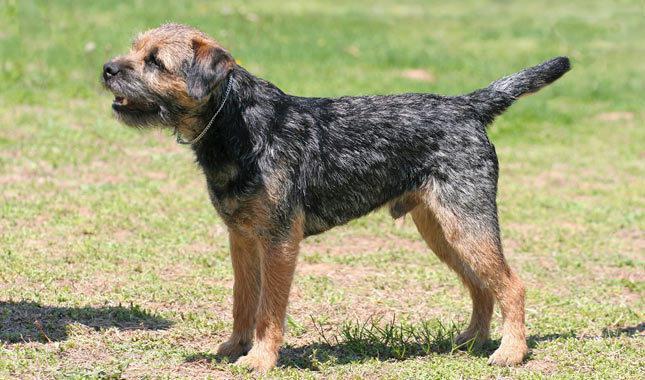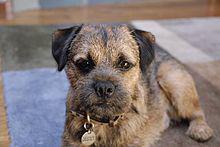The first image is the image on the left, the second image is the image on the right. For the images displayed, is the sentence "The dog in the image on the left is on a green grassy surface." factually correct? Answer yes or no. Yes. The first image is the image on the left, the second image is the image on the right. Analyze the images presented: Is the assertion "An image includes a standing dog with its body turned leftward and its tail extended outward." valid? Answer yes or no. Yes. 